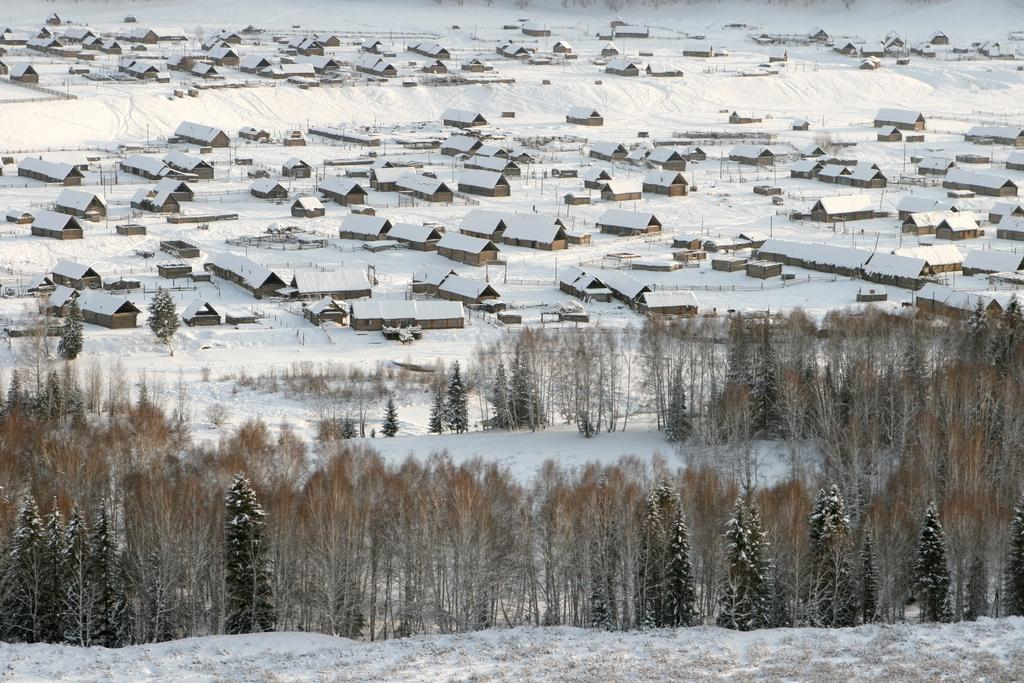What type of vegetation is present on the ground in the image? There are trees on the ground in the image. What is the weather like in the image? The snow visible in the background suggests that it is a snowy scene. What structures can be seen in the background of the image? There are houses in the background of the image. What type of scissorsors are being used to cut the snow in the image? There are no scissors present in the image, and the snow is not being cut. Is there a volcano visible in the image? No, there is no volcano present in the image. 